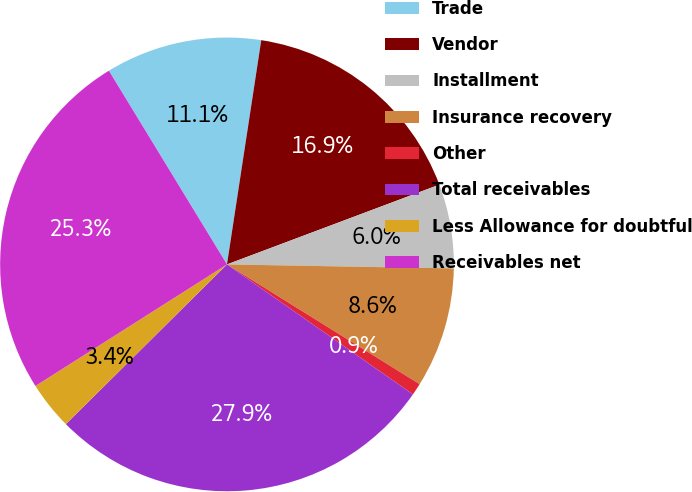<chart> <loc_0><loc_0><loc_500><loc_500><pie_chart><fcel>Trade<fcel>Vendor<fcel>Installment<fcel>Insurance recovery<fcel>Other<fcel>Total receivables<fcel>Less Allowance for doubtful<fcel>Receivables net<nl><fcel>11.13%<fcel>16.87%<fcel>6.0%<fcel>8.57%<fcel>0.86%<fcel>27.86%<fcel>3.43%<fcel>25.29%<nl></chart> 